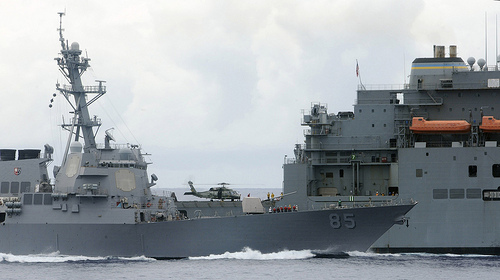<image>
Is the clouds on the ship? No. The clouds is not positioned on the ship. They may be near each other, but the clouds is not supported by or resting on top of the ship. 